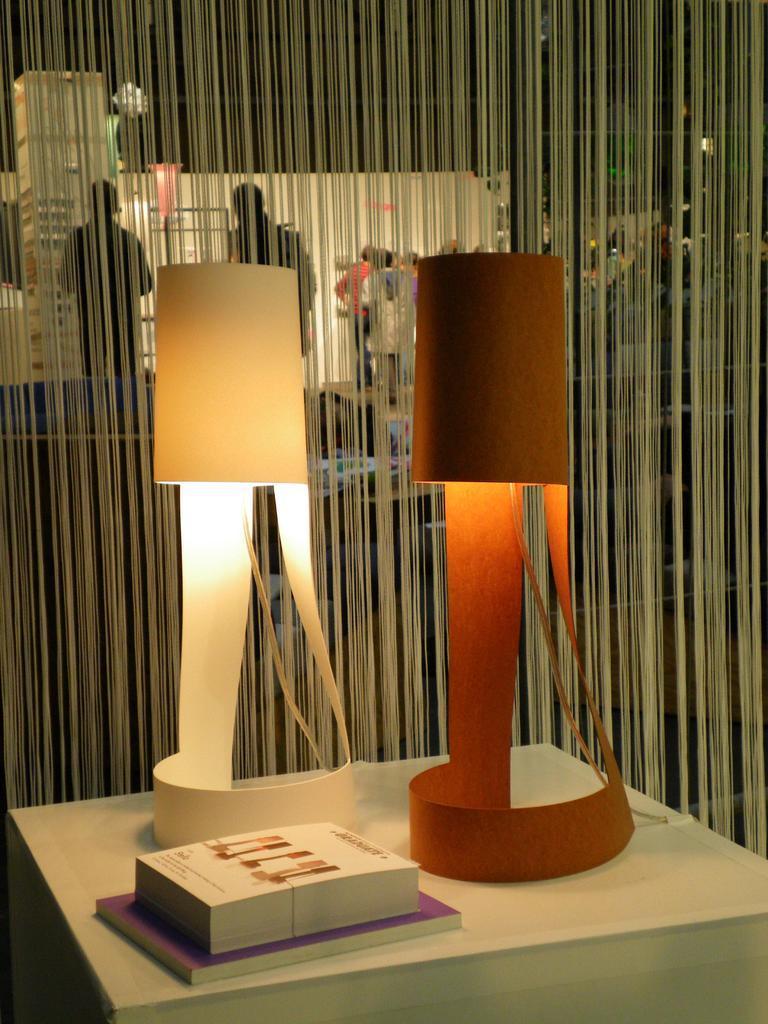Describe this image in one or two sentences. There is a platform. On that there are books and table lamps. In the back there is a curtain. Also there are many people in the background. 